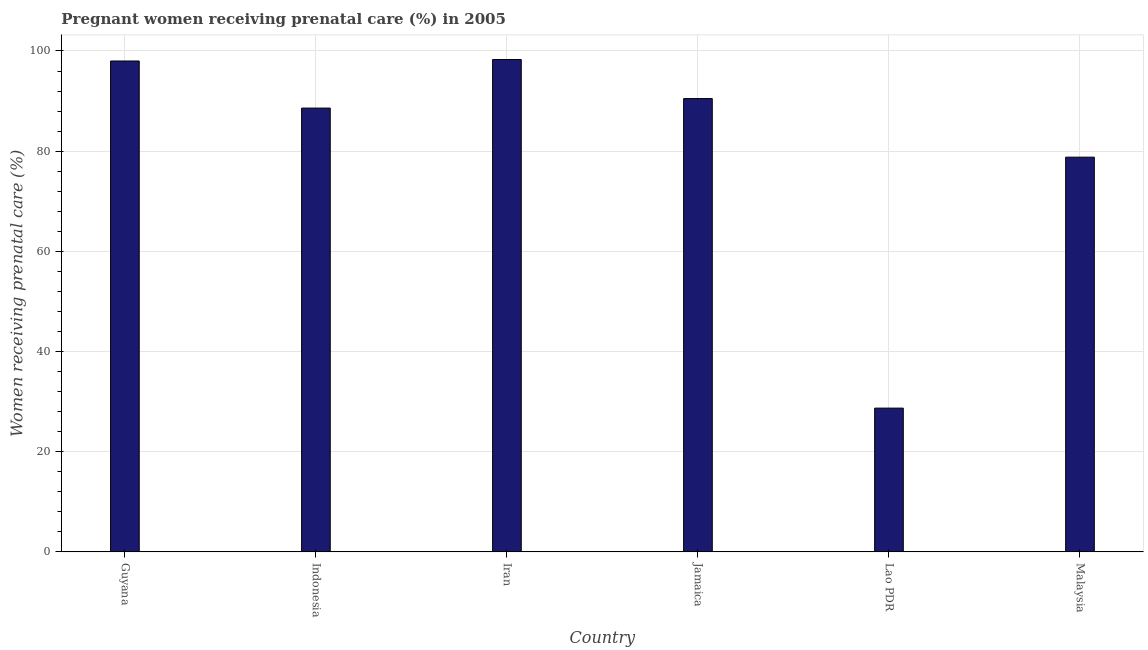Does the graph contain any zero values?
Keep it short and to the point. No. Does the graph contain grids?
Ensure brevity in your answer.  Yes. What is the title of the graph?
Provide a succinct answer. Pregnant women receiving prenatal care (%) in 2005. What is the label or title of the X-axis?
Offer a terse response. Country. What is the label or title of the Y-axis?
Give a very brief answer. Women receiving prenatal care (%). What is the percentage of pregnant women receiving prenatal care in Malaysia?
Keep it short and to the point. 78.8. Across all countries, what is the maximum percentage of pregnant women receiving prenatal care?
Provide a succinct answer. 98.3. Across all countries, what is the minimum percentage of pregnant women receiving prenatal care?
Provide a short and direct response. 28.7. In which country was the percentage of pregnant women receiving prenatal care maximum?
Give a very brief answer. Iran. In which country was the percentage of pregnant women receiving prenatal care minimum?
Your response must be concise. Lao PDR. What is the sum of the percentage of pregnant women receiving prenatal care?
Make the answer very short. 482.9. What is the difference between the percentage of pregnant women receiving prenatal care in Indonesia and Iran?
Provide a succinct answer. -9.7. What is the average percentage of pregnant women receiving prenatal care per country?
Make the answer very short. 80.48. What is the median percentage of pregnant women receiving prenatal care?
Your response must be concise. 89.55. What is the ratio of the percentage of pregnant women receiving prenatal care in Jamaica to that in Malaysia?
Keep it short and to the point. 1.15. Is the percentage of pregnant women receiving prenatal care in Lao PDR less than that in Malaysia?
Your answer should be very brief. Yes. Is the difference between the percentage of pregnant women receiving prenatal care in Guyana and Iran greater than the difference between any two countries?
Your response must be concise. No. What is the difference between the highest and the second highest percentage of pregnant women receiving prenatal care?
Provide a succinct answer. 0.3. What is the difference between the highest and the lowest percentage of pregnant women receiving prenatal care?
Make the answer very short. 69.6. In how many countries, is the percentage of pregnant women receiving prenatal care greater than the average percentage of pregnant women receiving prenatal care taken over all countries?
Give a very brief answer. 4. How many bars are there?
Your answer should be compact. 6. How many countries are there in the graph?
Ensure brevity in your answer.  6. What is the Women receiving prenatal care (%) of Indonesia?
Ensure brevity in your answer.  88.6. What is the Women receiving prenatal care (%) in Iran?
Give a very brief answer. 98.3. What is the Women receiving prenatal care (%) in Jamaica?
Your answer should be compact. 90.5. What is the Women receiving prenatal care (%) of Lao PDR?
Offer a terse response. 28.7. What is the Women receiving prenatal care (%) in Malaysia?
Your answer should be very brief. 78.8. What is the difference between the Women receiving prenatal care (%) in Guyana and Indonesia?
Keep it short and to the point. 9.4. What is the difference between the Women receiving prenatal care (%) in Guyana and Lao PDR?
Provide a succinct answer. 69.3. What is the difference between the Women receiving prenatal care (%) in Guyana and Malaysia?
Provide a short and direct response. 19.2. What is the difference between the Women receiving prenatal care (%) in Indonesia and Iran?
Give a very brief answer. -9.7. What is the difference between the Women receiving prenatal care (%) in Indonesia and Lao PDR?
Your answer should be compact. 59.9. What is the difference between the Women receiving prenatal care (%) in Indonesia and Malaysia?
Provide a short and direct response. 9.8. What is the difference between the Women receiving prenatal care (%) in Iran and Lao PDR?
Your answer should be very brief. 69.6. What is the difference between the Women receiving prenatal care (%) in Jamaica and Lao PDR?
Keep it short and to the point. 61.8. What is the difference between the Women receiving prenatal care (%) in Lao PDR and Malaysia?
Your answer should be very brief. -50.1. What is the ratio of the Women receiving prenatal care (%) in Guyana to that in Indonesia?
Your answer should be very brief. 1.11. What is the ratio of the Women receiving prenatal care (%) in Guyana to that in Iran?
Ensure brevity in your answer.  1. What is the ratio of the Women receiving prenatal care (%) in Guyana to that in Jamaica?
Keep it short and to the point. 1.08. What is the ratio of the Women receiving prenatal care (%) in Guyana to that in Lao PDR?
Offer a very short reply. 3.42. What is the ratio of the Women receiving prenatal care (%) in Guyana to that in Malaysia?
Ensure brevity in your answer.  1.24. What is the ratio of the Women receiving prenatal care (%) in Indonesia to that in Iran?
Keep it short and to the point. 0.9. What is the ratio of the Women receiving prenatal care (%) in Indonesia to that in Jamaica?
Offer a very short reply. 0.98. What is the ratio of the Women receiving prenatal care (%) in Indonesia to that in Lao PDR?
Offer a very short reply. 3.09. What is the ratio of the Women receiving prenatal care (%) in Indonesia to that in Malaysia?
Provide a short and direct response. 1.12. What is the ratio of the Women receiving prenatal care (%) in Iran to that in Jamaica?
Provide a succinct answer. 1.09. What is the ratio of the Women receiving prenatal care (%) in Iran to that in Lao PDR?
Keep it short and to the point. 3.42. What is the ratio of the Women receiving prenatal care (%) in Iran to that in Malaysia?
Ensure brevity in your answer.  1.25. What is the ratio of the Women receiving prenatal care (%) in Jamaica to that in Lao PDR?
Ensure brevity in your answer.  3.15. What is the ratio of the Women receiving prenatal care (%) in Jamaica to that in Malaysia?
Your response must be concise. 1.15. What is the ratio of the Women receiving prenatal care (%) in Lao PDR to that in Malaysia?
Provide a succinct answer. 0.36. 